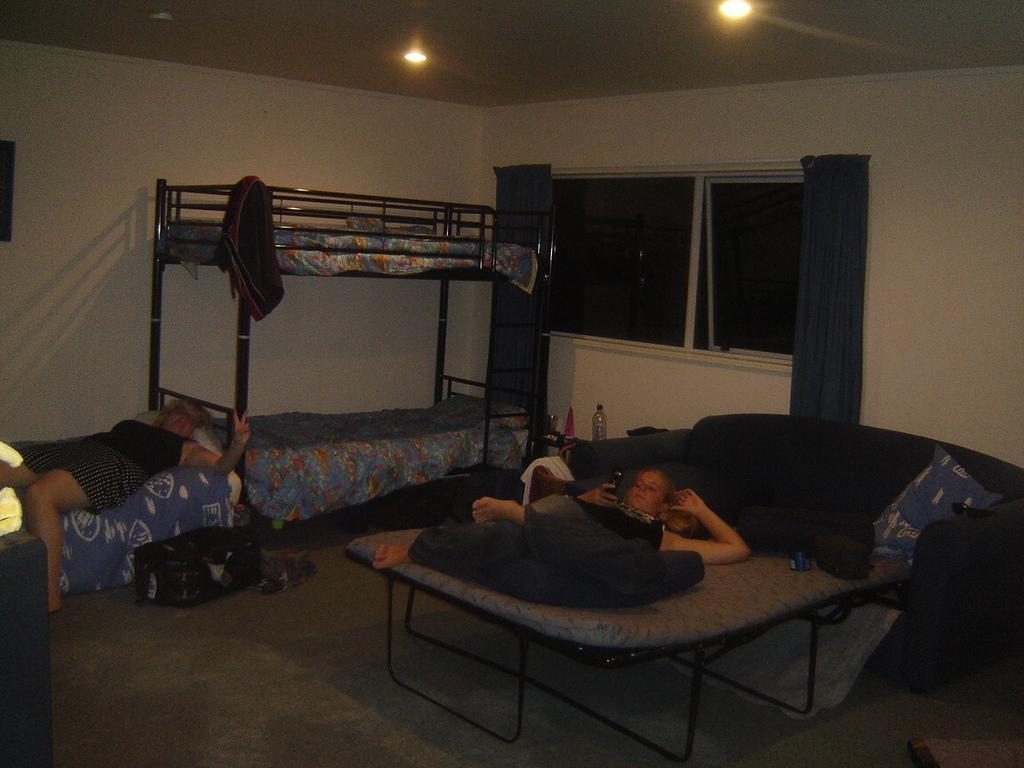How would you summarize this image in a sentence or two? The picture is taken inside a room. In this picture we can see beds, blankets, bags, bottle, people and various objects. In the background we can see curtains, windows and wall. At the top we can see ceiling and light. On the left there is disc and yellow color object. 